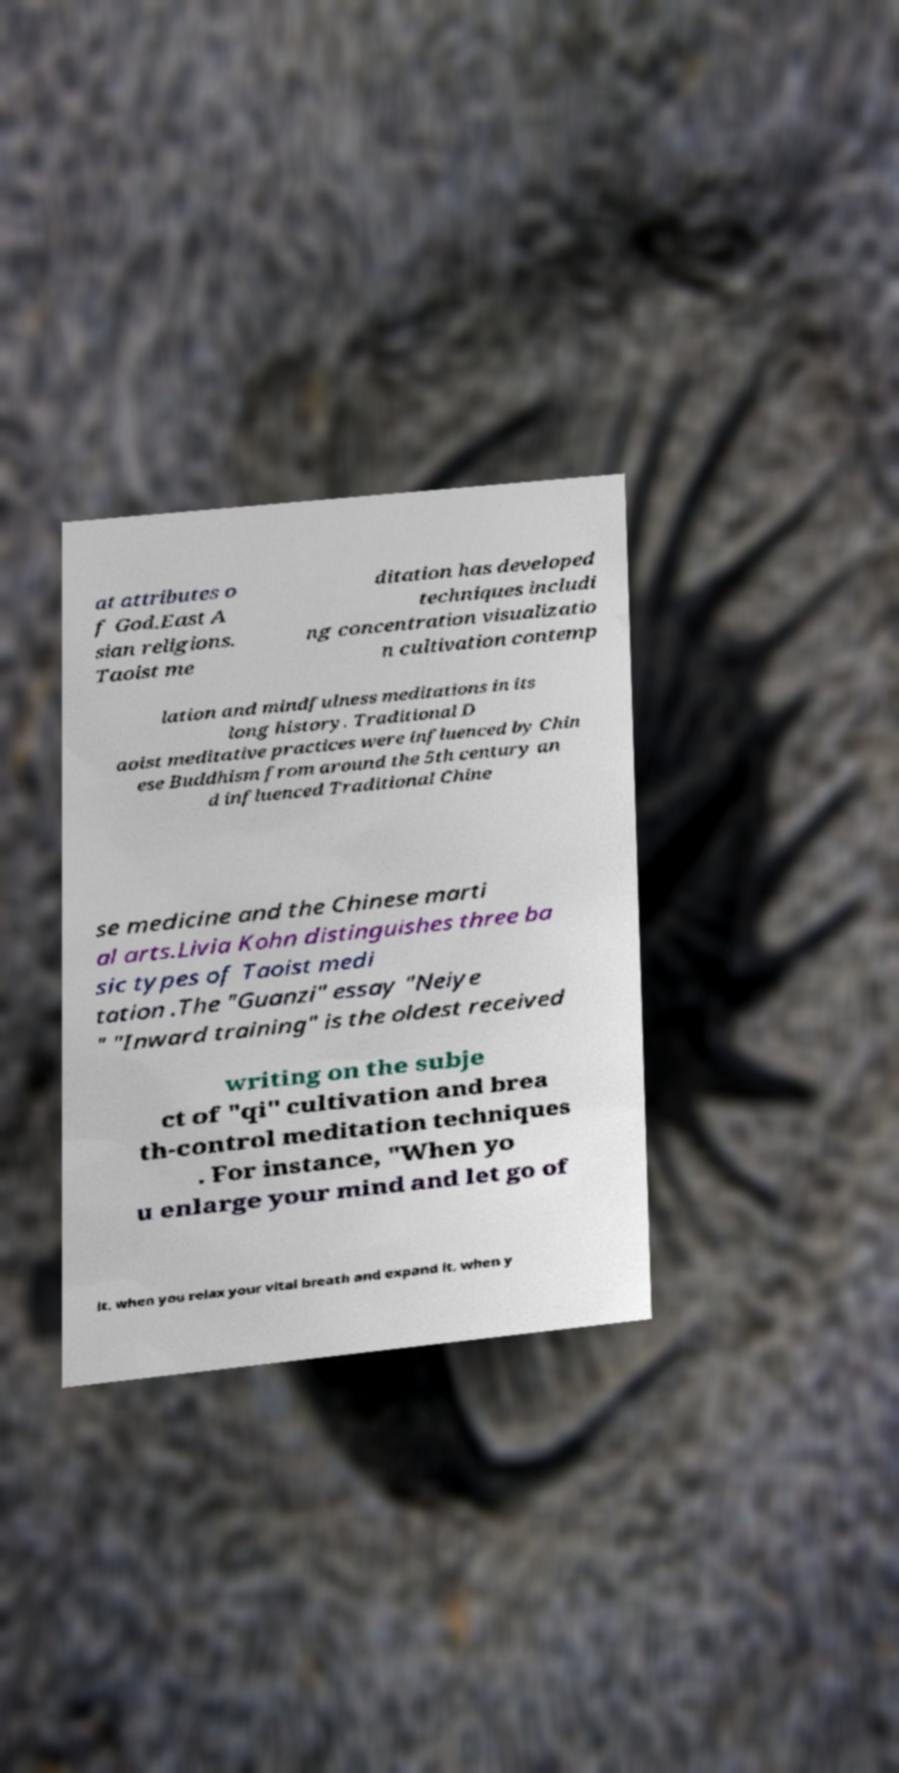Can you accurately transcribe the text from the provided image for me? at attributes o f God.East A sian religions. Taoist me ditation has developed techniques includi ng concentration visualizatio n cultivation contemp lation and mindfulness meditations in its long history. Traditional D aoist meditative practices were influenced by Chin ese Buddhism from around the 5th century an d influenced Traditional Chine se medicine and the Chinese marti al arts.Livia Kohn distinguishes three ba sic types of Taoist medi tation .The "Guanzi" essay "Neiye " "Inward training" is the oldest received writing on the subje ct of "qi" cultivation and brea th-control meditation techniques . For instance, "When yo u enlarge your mind and let go of it, when you relax your vital breath and expand it, when y 